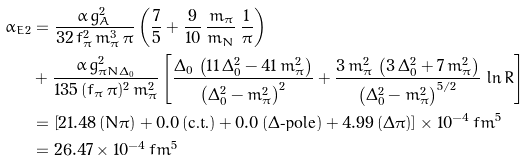<formula> <loc_0><loc_0><loc_500><loc_500>\bar { \alpha } _ { E 2 } & = \frac { \alpha \, g _ { A } ^ { 2 } } { 3 2 \, f _ { \pi } ^ { 2 } \, m _ { \pi } ^ { 3 } \, \pi } \left ( \frac { 7 } { 5 } + \frac { 9 } { 1 0 } \, \frac { m _ { \pi } } { m _ { N } } \, \frac { 1 } { \pi } \right ) \\ & + \frac { \alpha \, g _ { \pi N \Delta _ { 0 } } ^ { 2 } } { 1 3 5 \, ( f _ { \pi } \, \pi ) ^ { 2 } \, m _ { \pi } ^ { 2 } } \left [ \frac { \Delta _ { 0 } \, \left ( 1 1 \, \Delta _ { 0 } ^ { 2 } - 4 1 \, m _ { \pi } ^ { 2 } \right ) } { \left ( \Delta _ { 0 } ^ { 2 } - m _ { \pi } ^ { 2 } \right ) ^ { 2 } } + \frac { 3 \, m _ { \pi } ^ { 2 } \, \left ( 3 \, \Delta _ { 0 } ^ { 2 } + 7 \, m _ { \pi } ^ { 2 } \right ) } { \left ( \Delta _ { 0 } ^ { 2 } - m _ { \pi } ^ { 2 } \right ) ^ { 5 / 2 } } \, \ln R \right ] \quad \\ & = \left [ 2 1 . 4 8 \, ( N \pi ) + 0 . 0 \, ( \text {c.t.} ) + 0 . 0 \, ( \Delta \text {-pole} ) + 4 . 9 9 \, ( \Delta \pi ) \right ] \times 1 0 ^ { - 4 } \, f m ^ { 5 } \\ & = 2 6 . 4 7 \times 1 0 ^ { - 4 } \, f m ^ { 5 }</formula> 